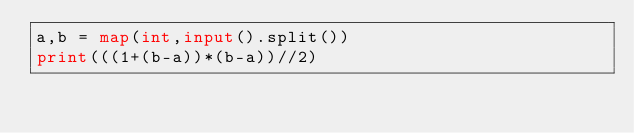<code> <loc_0><loc_0><loc_500><loc_500><_Python_>a,b = map(int,input().split())
print(((1+(b-a))*(b-a))//2)
</code> 